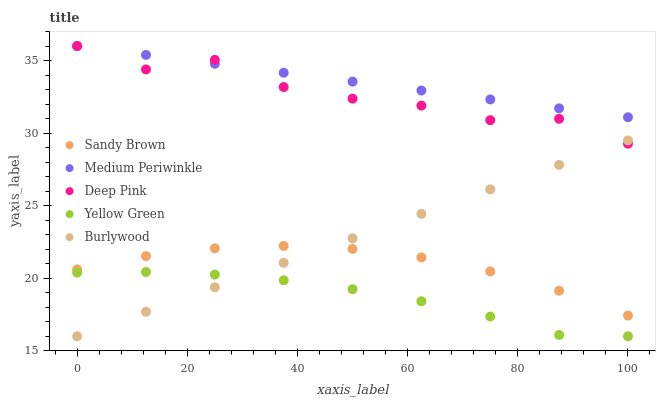Does Yellow Green have the minimum area under the curve?
Answer yes or no. Yes. Does Medium Periwinkle have the maximum area under the curve?
Answer yes or no. Yes. Does Deep Pink have the minimum area under the curve?
Answer yes or no. No. Does Deep Pink have the maximum area under the curve?
Answer yes or no. No. Is Medium Periwinkle the smoothest?
Answer yes or no. Yes. Is Deep Pink the roughest?
Answer yes or no. Yes. Is Deep Pink the smoothest?
Answer yes or no. No. Is Medium Periwinkle the roughest?
Answer yes or no. No. Does Burlywood have the lowest value?
Answer yes or no. Yes. Does Deep Pink have the lowest value?
Answer yes or no. No. Does Deep Pink have the highest value?
Answer yes or no. Yes. Does Sandy Brown have the highest value?
Answer yes or no. No. Is Sandy Brown less than Medium Periwinkle?
Answer yes or no. Yes. Is Medium Periwinkle greater than Sandy Brown?
Answer yes or no. Yes. Does Medium Periwinkle intersect Deep Pink?
Answer yes or no. Yes. Is Medium Periwinkle less than Deep Pink?
Answer yes or no. No. Is Medium Periwinkle greater than Deep Pink?
Answer yes or no. No. Does Sandy Brown intersect Medium Periwinkle?
Answer yes or no. No. 